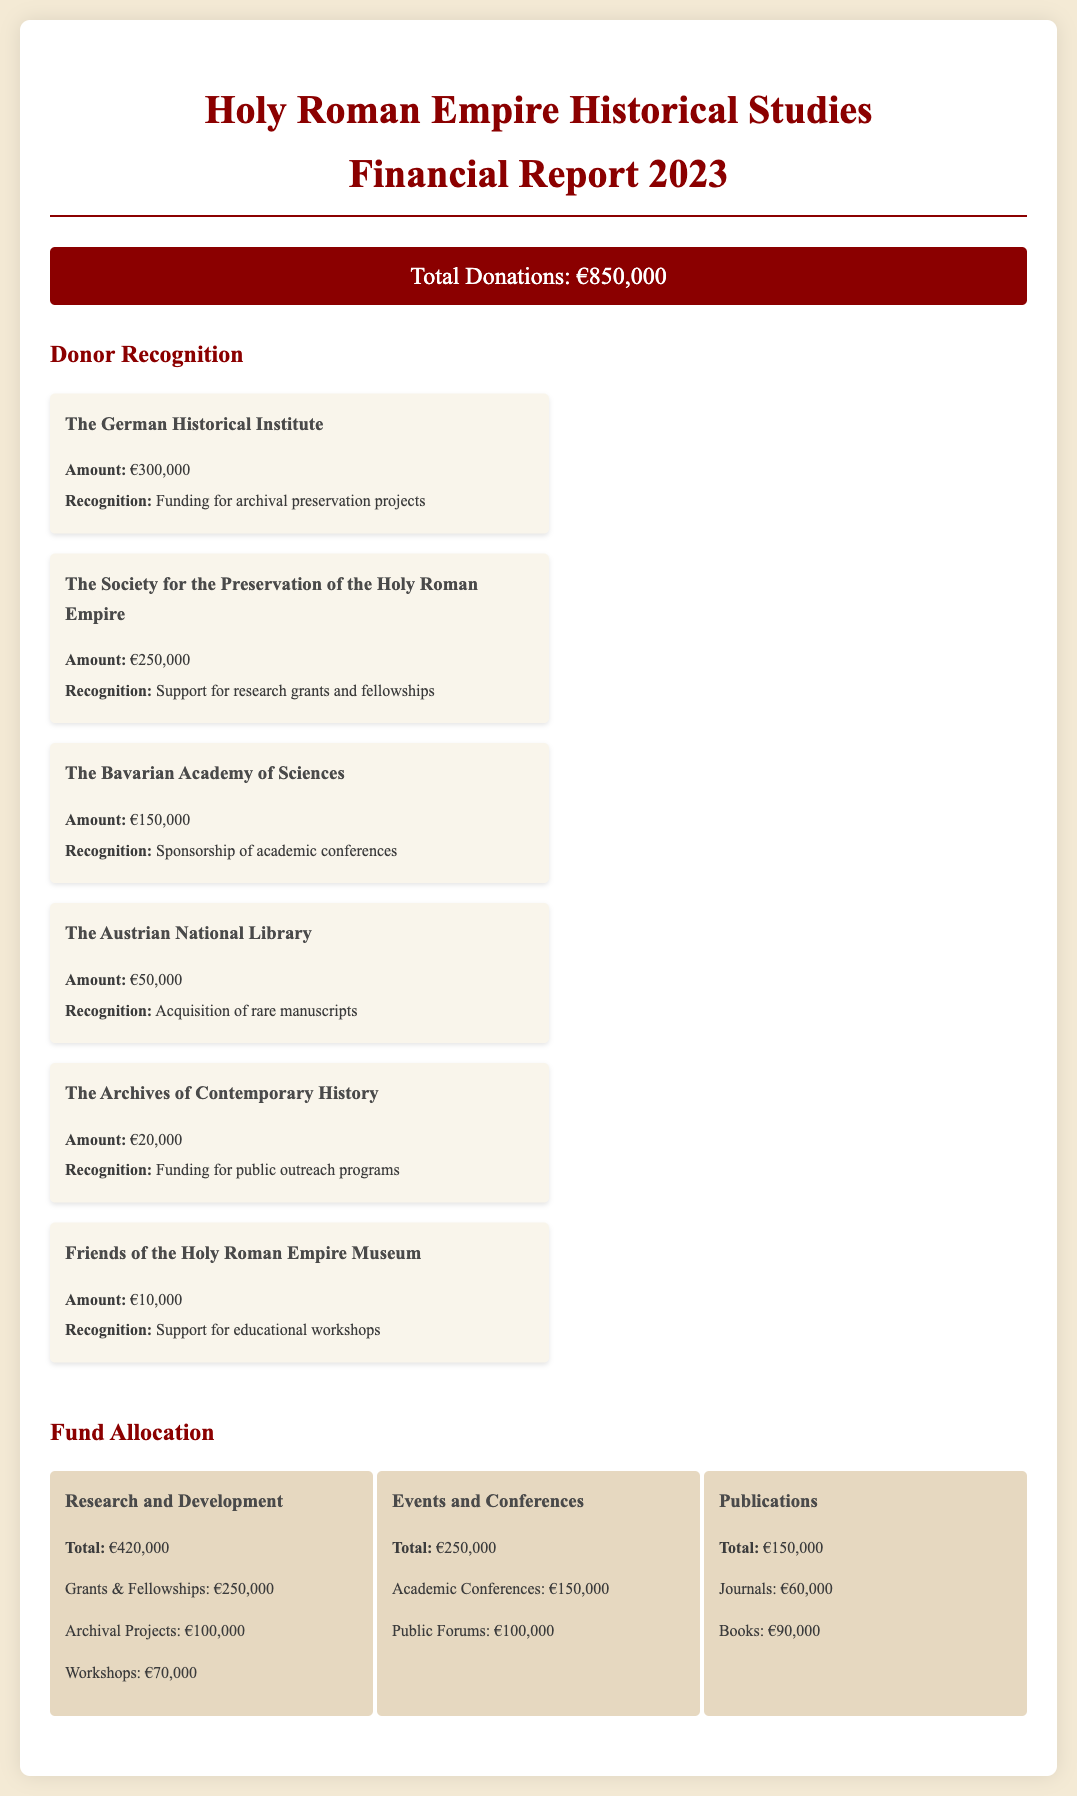What is the total amount of donations? The total amount of donations is explicitly stated in the document.
Answer: €850,000 Who donated the most amount? The document lists the donors along with their donation amounts, and the highest is specified.
Answer: The German Historical Institute What is the donation amount from the Society for the Preservation of the Holy Roman Empire? The document provides the donation amount for each recognized patron.
Answer: €250,000 What is the total fund allocation for Research and Development? The document details fund allocation into categories, including the total for Research and Development.
Answer: €420,000 How much funding was provided for public outreach programs? The recognition section includes details on which categories received funds, including this specific program.
Answer: €20,000 What percentage of total donations is allocated to Events and Conferences? To find this percentage, refer to the total donations and amounts allocated to Events and Conferences.
Answer: 29.41% How much was allocated for academic conferences specifically? The fund allocation section breaks down funding into specific categories.
Answer: €150,000 What recognition was given for the donation from the Bavarian Academy of Sciences? The document specifies the purpose of each patron's donation.
Answer: Sponsorship of academic conferences Which fund category received the least amount of allocation? The document details total allocations across several fund categories.
Answer: Publications 